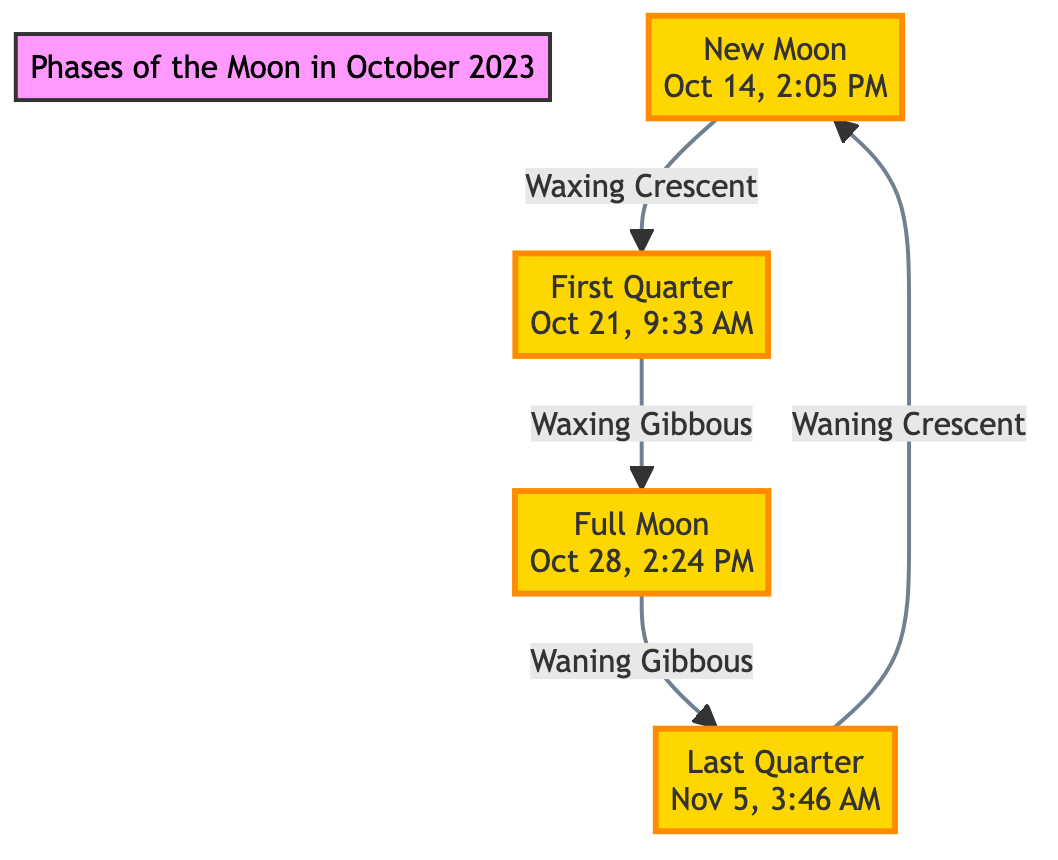What is the date and time of the New Moon? The New Moon is indicated in the diagram as occurring on October 14 at 2:05 PM. This specific date and time are shown directly within the New Moon node.
Answer: October 14, 2:05 PM What phase occurs after the First Quarter? The diagram shows a direct flow from the First Quarter phase to the Full Moon phase. Thus, the phase after the First Quarter is the Full Moon.
Answer: Full Moon What is the last lunar phase depicted in the diagram? The sequence in the diagram ends with the Last Quarter phase, which is indicated as the final phase before returning to the New Moon. This information comes from following the arrows in the diagram.
Answer: Last Quarter How many distinct phases are represented in the diagram? By counting the nodes for each phase labeled in the diagram (New Moon, First Quarter, Full Moon, Last Quarter), there are a total of four distinct phases.
Answer: Four What is the relationship between the Full Moon and the Last Quarter? The diagram shows that after the Full Moon, the next phase is the Last Quarter, indicating a relationship where the Last Quarter follows the Full Moon in the lunar cycle.
Answer: Last Quarter follows Full Moon At what time does the Full Moon occur? The time for the Full Moon is specifically indicated in the diagram as October 28 at 2:24 PM, which can be directly found within the Full Moon node.
Answer: October 28, 2:24 PM What phase is depicted as occurring before the New Moon? The diagram clearly shows that the phase preceding the New Moon is the Waning Crescent, as indicated when tracing the direction in the cycle.
Answer: Waning Crescent Which specific phase occurs on October 21? The First Quarter phase is highlighted in the diagram for October 21 at 9:33 AM. This specific date and time are noted directly within the First Quarter node.
Answer: First Quarter What is the movement direction of the phases in the diagram? The diagram shows a clockwise movement from one phase to the next, which is indicated by the arrows connecting each phase.
Answer: Clockwise 